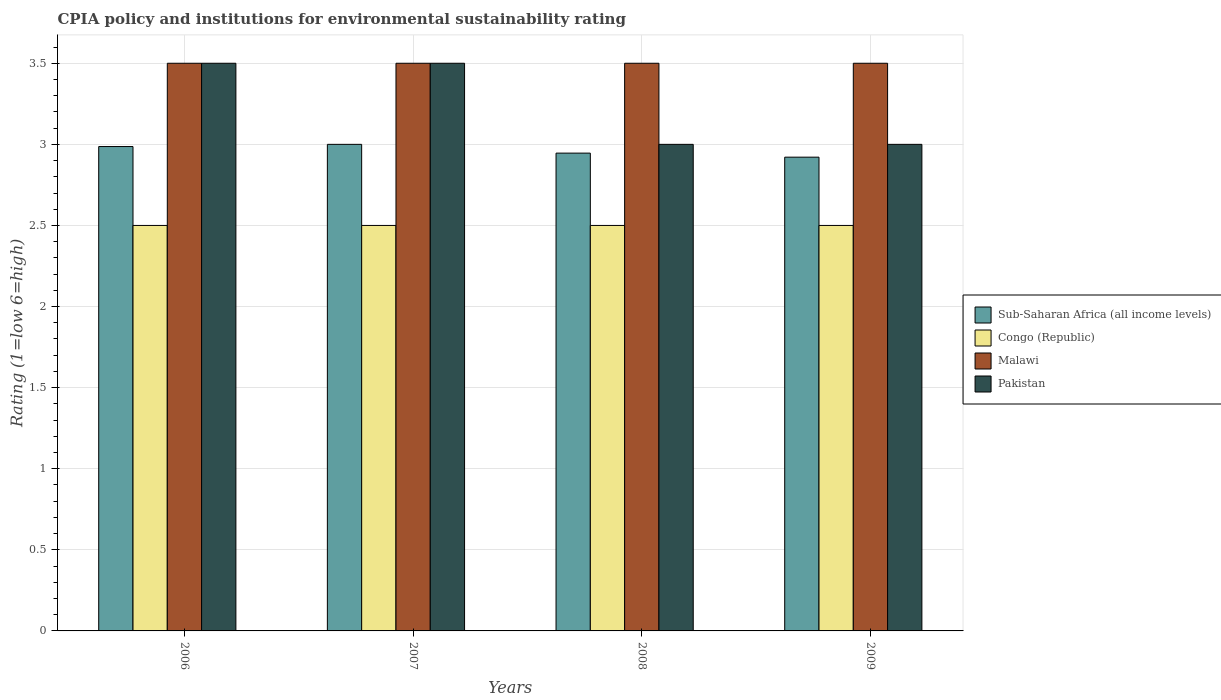How many different coloured bars are there?
Your answer should be very brief. 4. Are the number of bars on each tick of the X-axis equal?
Make the answer very short. Yes. In how many cases, is the number of bars for a given year not equal to the number of legend labels?
Keep it short and to the point. 0. What is the CPIA rating in Sub-Saharan Africa (all income levels) in 2008?
Your response must be concise. 2.95. Across all years, what is the maximum CPIA rating in Malawi?
Make the answer very short. 3.5. Across all years, what is the minimum CPIA rating in Malawi?
Give a very brief answer. 3.5. What is the average CPIA rating in Malawi per year?
Your response must be concise. 3.5. In the year 2008, what is the difference between the CPIA rating in Pakistan and CPIA rating in Congo (Republic)?
Your answer should be very brief. 0.5. What is the ratio of the CPIA rating in Congo (Republic) in 2006 to that in 2007?
Give a very brief answer. 1. Is the CPIA rating in Pakistan in 2006 less than that in 2007?
Make the answer very short. No. Is the difference between the CPIA rating in Pakistan in 2006 and 2009 greater than the difference between the CPIA rating in Congo (Republic) in 2006 and 2009?
Your response must be concise. Yes. What is the difference between the highest and the second highest CPIA rating in Malawi?
Give a very brief answer. 0. What is the difference between the highest and the lowest CPIA rating in Congo (Republic)?
Offer a very short reply. 0. Is the sum of the CPIA rating in Malawi in 2006 and 2007 greater than the maximum CPIA rating in Congo (Republic) across all years?
Your answer should be compact. Yes. Is it the case that in every year, the sum of the CPIA rating in Pakistan and CPIA rating in Malawi is greater than the sum of CPIA rating in Sub-Saharan Africa (all income levels) and CPIA rating in Congo (Republic)?
Offer a terse response. Yes. What does the 2nd bar from the left in 2006 represents?
Your response must be concise. Congo (Republic). What does the 4th bar from the right in 2006 represents?
Ensure brevity in your answer.  Sub-Saharan Africa (all income levels). Are all the bars in the graph horizontal?
Provide a short and direct response. No. How many years are there in the graph?
Provide a short and direct response. 4. Does the graph contain any zero values?
Offer a very short reply. No. Where does the legend appear in the graph?
Your response must be concise. Center right. How are the legend labels stacked?
Your answer should be compact. Vertical. What is the title of the graph?
Keep it short and to the point. CPIA policy and institutions for environmental sustainability rating. Does "Suriname" appear as one of the legend labels in the graph?
Ensure brevity in your answer.  No. What is the Rating (1=low 6=high) in Sub-Saharan Africa (all income levels) in 2006?
Keep it short and to the point. 2.99. What is the Rating (1=low 6=high) of Pakistan in 2007?
Make the answer very short. 3.5. What is the Rating (1=low 6=high) in Sub-Saharan Africa (all income levels) in 2008?
Offer a very short reply. 2.95. What is the Rating (1=low 6=high) in Malawi in 2008?
Provide a succinct answer. 3.5. What is the Rating (1=low 6=high) of Pakistan in 2008?
Keep it short and to the point. 3. What is the Rating (1=low 6=high) of Sub-Saharan Africa (all income levels) in 2009?
Your answer should be compact. 2.92. What is the Rating (1=low 6=high) in Malawi in 2009?
Provide a succinct answer. 3.5. What is the Rating (1=low 6=high) in Pakistan in 2009?
Offer a very short reply. 3. Across all years, what is the maximum Rating (1=low 6=high) in Congo (Republic)?
Provide a succinct answer. 2.5. Across all years, what is the maximum Rating (1=low 6=high) of Pakistan?
Offer a terse response. 3.5. Across all years, what is the minimum Rating (1=low 6=high) of Sub-Saharan Africa (all income levels)?
Make the answer very short. 2.92. Across all years, what is the minimum Rating (1=low 6=high) in Malawi?
Keep it short and to the point. 3.5. Across all years, what is the minimum Rating (1=low 6=high) of Pakistan?
Provide a short and direct response. 3. What is the total Rating (1=low 6=high) of Sub-Saharan Africa (all income levels) in the graph?
Make the answer very short. 11.85. What is the total Rating (1=low 6=high) of Malawi in the graph?
Ensure brevity in your answer.  14. What is the total Rating (1=low 6=high) of Pakistan in the graph?
Your answer should be very brief. 13. What is the difference between the Rating (1=low 6=high) in Sub-Saharan Africa (all income levels) in 2006 and that in 2007?
Make the answer very short. -0.01. What is the difference between the Rating (1=low 6=high) of Malawi in 2006 and that in 2007?
Offer a terse response. 0. What is the difference between the Rating (1=low 6=high) in Sub-Saharan Africa (all income levels) in 2006 and that in 2008?
Your answer should be compact. 0.04. What is the difference between the Rating (1=low 6=high) of Sub-Saharan Africa (all income levels) in 2006 and that in 2009?
Provide a short and direct response. 0.07. What is the difference between the Rating (1=low 6=high) in Malawi in 2006 and that in 2009?
Your answer should be very brief. 0. What is the difference between the Rating (1=low 6=high) of Sub-Saharan Africa (all income levels) in 2007 and that in 2008?
Offer a very short reply. 0.05. What is the difference between the Rating (1=low 6=high) in Congo (Republic) in 2007 and that in 2008?
Make the answer very short. 0. What is the difference between the Rating (1=low 6=high) in Malawi in 2007 and that in 2008?
Keep it short and to the point. 0. What is the difference between the Rating (1=low 6=high) of Sub-Saharan Africa (all income levels) in 2007 and that in 2009?
Give a very brief answer. 0.08. What is the difference between the Rating (1=low 6=high) in Pakistan in 2007 and that in 2009?
Your answer should be compact. 0.5. What is the difference between the Rating (1=low 6=high) in Sub-Saharan Africa (all income levels) in 2008 and that in 2009?
Give a very brief answer. 0.02. What is the difference between the Rating (1=low 6=high) of Congo (Republic) in 2008 and that in 2009?
Give a very brief answer. 0. What is the difference between the Rating (1=low 6=high) of Pakistan in 2008 and that in 2009?
Provide a succinct answer. 0. What is the difference between the Rating (1=low 6=high) of Sub-Saharan Africa (all income levels) in 2006 and the Rating (1=low 6=high) of Congo (Republic) in 2007?
Keep it short and to the point. 0.49. What is the difference between the Rating (1=low 6=high) of Sub-Saharan Africa (all income levels) in 2006 and the Rating (1=low 6=high) of Malawi in 2007?
Offer a terse response. -0.51. What is the difference between the Rating (1=low 6=high) in Sub-Saharan Africa (all income levels) in 2006 and the Rating (1=low 6=high) in Pakistan in 2007?
Make the answer very short. -0.51. What is the difference between the Rating (1=low 6=high) in Congo (Republic) in 2006 and the Rating (1=low 6=high) in Malawi in 2007?
Offer a very short reply. -1. What is the difference between the Rating (1=low 6=high) in Malawi in 2006 and the Rating (1=low 6=high) in Pakistan in 2007?
Offer a terse response. 0. What is the difference between the Rating (1=low 6=high) of Sub-Saharan Africa (all income levels) in 2006 and the Rating (1=low 6=high) of Congo (Republic) in 2008?
Ensure brevity in your answer.  0.49. What is the difference between the Rating (1=low 6=high) of Sub-Saharan Africa (all income levels) in 2006 and the Rating (1=low 6=high) of Malawi in 2008?
Offer a very short reply. -0.51. What is the difference between the Rating (1=low 6=high) in Sub-Saharan Africa (all income levels) in 2006 and the Rating (1=low 6=high) in Pakistan in 2008?
Offer a very short reply. -0.01. What is the difference between the Rating (1=low 6=high) in Malawi in 2006 and the Rating (1=low 6=high) in Pakistan in 2008?
Provide a short and direct response. 0.5. What is the difference between the Rating (1=low 6=high) of Sub-Saharan Africa (all income levels) in 2006 and the Rating (1=low 6=high) of Congo (Republic) in 2009?
Keep it short and to the point. 0.49. What is the difference between the Rating (1=low 6=high) in Sub-Saharan Africa (all income levels) in 2006 and the Rating (1=low 6=high) in Malawi in 2009?
Give a very brief answer. -0.51. What is the difference between the Rating (1=low 6=high) of Sub-Saharan Africa (all income levels) in 2006 and the Rating (1=low 6=high) of Pakistan in 2009?
Make the answer very short. -0.01. What is the difference between the Rating (1=low 6=high) in Congo (Republic) in 2006 and the Rating (1=low 6=high) in Pakistan in 2009?
Make the answer very short. -0.5. What is the difference between the Rating (1=low 6=high) in Malawi in 2006 and the Rating (1=low 6=high) in Pakistan in 2009?
Offer a terse response. 0.5. What is the difference between the Rating (1=low 6=high) in Sub-Saharan Africa (all income levels) in 2007 and the Rating (1=low 6=high) in Congo (Republic) in 2008?
Offer a very short reply. 0.5. What is the difference between the Rating (1=low 6=high) in Sub-Saharan Africa (all income levels) in 2007 and the Rating (1=low 6=high) in Malawi in 2008?
Your answer should be very brief. -0.5. What is the difference between the Rating (1=low 6=high) of Sub-Saharan Africa (all income levels) in 2007 and the Rating (1=low 6=high) of Pakistan in 2008?
Your answer should be very brief. 0. What is the difference between the Rating (1=low 6=high) in Congo (Republic) in 2007 and the Rating (1=low 6=high) in Malawi in 2008?
Your response must be concise. -1. What is the difference between the Rating (1=low 6=high) in Congo (Republic) in 2007 and the Rating (1=low 6=high) in Pakistan in 2008?
Keep it short and to the point. -0.5. What is the difference between the Rating (1=low 6=high) in Sub-Saharan Africa (all income levels) in 2007 and the Rating (1=low 6=high) in Malawi in 2009?
Offer a very short reply. -0.5. What is the difference between the Rating (1=low 6=high) in Malawi in 2007 and the Rating (1=low 6=high) in Pakistan in 2009?
Offer a terse response. 0.5. What is the difference between the Rating (1=low 6=high) in Sub-Saharan Africa (all income levels) in 2008 and the Rating (1=low 6=high) in Congo (Republic) in 2009?
Make the answer very short. 0.45. What is the difference between the Rating (1=low 6=high) in Sub-Saharan Africa (all income levels) in 2008 and the Rating (1=low 6=high) in Malawi in 2009?
Provide a short and direct response. -0.55. What is the difference between the Rating (1=low 6=high) in Sub-Saharan Africa (all income levels) in 2008 and the Rating (1=low 6=high) in Pakistan in 2009?
Offer a very short reply. -0.05. What is the difference between the Rating (1=low 6=high) of Congo (Republic) in 2008 and the Rating (1=low 6=high) of Malawi in 2009?
Ensure brevity in your answer.  -1. What is the average Rating (1=low 6=high) of Sub-Saharan Africa (all income levels) per year?
Offer a very short reply. 2.96. What is the average Rating (1=low 6=high) in Congo (Republic) per year?
Offer a terse response. 2.5. What is the average Rating (1=low 6=high) of Pakistan per year?
Provide a succinct answer. 3.25. In the year 2006, what is the difference between the Rating (1=low 6=high) in Sub-Saharan Africa (all income levels) and Rating (1=low 6=high) in Congo (Republic)?
Offer a very short reply. 0.49. In the year 2006, what is the difference between the Rating (1=low 6=high) in Sub-Saharan Africa (all income levels) and Rating (1=low 6=high) in Malawi?
Make the answer very short. -0.51. In the year 2006, what is the difference between the Rating (1=low 6=high) of Sub-Saharan Africa (all income levels) and Rating (1=low 6=high) of Pakistan?
Keep it short and to the point. -0.51. In the year 2006, what is the difference between the Rating (1=low 6=high) of Congo (Republic) and Rating (1=low 6=high) of Malawi?
Your response must be concise. -1. In the year 2007, what is the difference between the Rating (1=low 6=high) in Sub-Saharan Africa (all income levels) and Rating (1=low 6=high) in Malawi?
Your response must be concise. -0.5. In the year 2007, what is the difference between the Rating (1=low 6=high) in Sub-Saharan Africa (all income levels) and Rating (1=low 6=high) in Pakistan?
Provide a short and direct response. -0.5. In the year 2007, what is the difference between the Rating (1=low 6=high) in Malawi and Rating (1=low 6=high) in Pakistan?
Give a very brief answer. 0. In the year 2008, what is the difference between the Rating (1=low 6=high) in Sub-Saharan Africa (all income levels) and Rating (1=low 6=high) in Congo (Republic)?
Your answer should be very brief. 0.45. In the year 2008, what is the difference between the Rating (1=low 6=high) of Sub-Saharan Africa (all income levels) and Rating (1=low 6=high) of Malawi?
Provide a succinct answer. -0.55. In the year 2008, what is the difference between the Rating (1=low 6=high) of Sub-Saharan Africa (all income levels) and Rating (1=low 6=high) of Pakistan?
Provide a short and direct response. -0.05. In the year 2008, what is the difference between the Rating (1=low 6=high) in Congo (Republic) and Rating (1=low 6=high) in Malawi?
Provide a succinct answer. -1. In the year 2008, what is the difference between the Rating (1=low 6=high) of Congo (Republic) and Rating (1=low 6=high) of Pakistan?
Offer a very short reply. -0.5. In the year 2009, what is the difference between the Rating (1=low 6=high) of Sub-Saharan Africa (all income levels) and Rating (1=low 6=high) of Congo (Republic)?
Your answer should be very brief. 0.42. In the year 2009, what is the difference between the Rating (1=low 6=high) of Sub-Saharan Africa (all income levels) and Rating (1=low 6=high) of Malawi?
Your answer should be compact. -0.58. In the year 2009, what is the difference between the Rating (1=low 6=high) in Sub-Saharan Africa (all income levels) and Rating (1=low 6=high) in Pakistan?
Provide a short and direct response. -0.08. In the year 2009, what is the difference between the Rating (1=low 6=high) of Congo (Republic) and Rating (1=low 6=high) of Malawi?
Offer a very short reply. -1. In the year 2009, what is the difference between the Rating (1=low 6=high) in Malawi and Rating (1=low 6=high) in Pakistan?
Your response must be concise. 0.5. What is the ratio of the Rating (1=low 6=high) in Pakistan in 2006 to that in 2007?
Your answer should be very brief. 1. What is the ratio of the Rating (1=low 6=high) in Sub-Saharan Africa (all income levels) in 2006 to that in 2008?
Offer a very short reply. 1.01. What is the ratio of the Rating (1=low 6=high) in Congo (Republic) in 2006 to that in 2008?
Give a very brief answer. 1. What is the ratio of the Rating (1=low 6=high) in Malawi in 2006 to that in 2008?
Your answer should be compact. 1. What is the ratio of the Rating (1=low 6=high) in Pakistan in 2006 to that in 2008?
Provide a succinct answer. 1.17. What is the ratio of the Rating (1=low 6=high) in Sub-Saharan Africa (all income levels) in 2006 to that in 2009?
Provide a short and direct response. 1.02. What is the ratio of the Rating (1=low 6=high) of Congo (Republic) in 2006 to that in 2009?
Keep it short and to the point. 1. What is the ratio of the Rating (1=low 6=high) in Sub-Saharan Africa (all income levels) in 2007 to that in 2008?
Offer a very short reply. 1.02. What is the ratio of the Rating (1=low 6=high) of Congo (Republic) in 2007 to that in 2008?
Ensure brevity in your answer.  1. What is the ratio of the Rating (1=low 6=high) of Sub-Saharan Africa (all income levels) in 2007 to that in 2009?
Give a very brief answer. 1.03. What is the ratio of the Rating (1=low 6=high) of Malawi in 2007 to that in 2009?
Your response must be concise. 1. What is the ratio of the Rating (1=low 6=high) of Sub-Saharan Africa (all income levels) in 2008 to that in 2009?
Your answer should be very brief. 1.01. What is the ratio of the Rating (1=low 6=high) of Malawi in 2008 to that in 2009?
Your answer should be compact. 1. What is the difference between the highest and the second highest Rating (1=low 6=high) in Sub-Saharan Africa (all income levels)?
Make the answer very short. 0.01. What is the difference between the highest and the lowest Rating (1=low 6=high) in Sub-Saharan Africa (all income levels)?
Keep it short and to the point. 0.08. What is the difference between the highest and the lowest Rating (1=low 6=high) of Malawi?
Provide a succinct answer. 0. What is the difference between the highest and the lowest Rating (1=low 6=high) in Pakistan?
Ensure brevity in your answer.  0.5. 